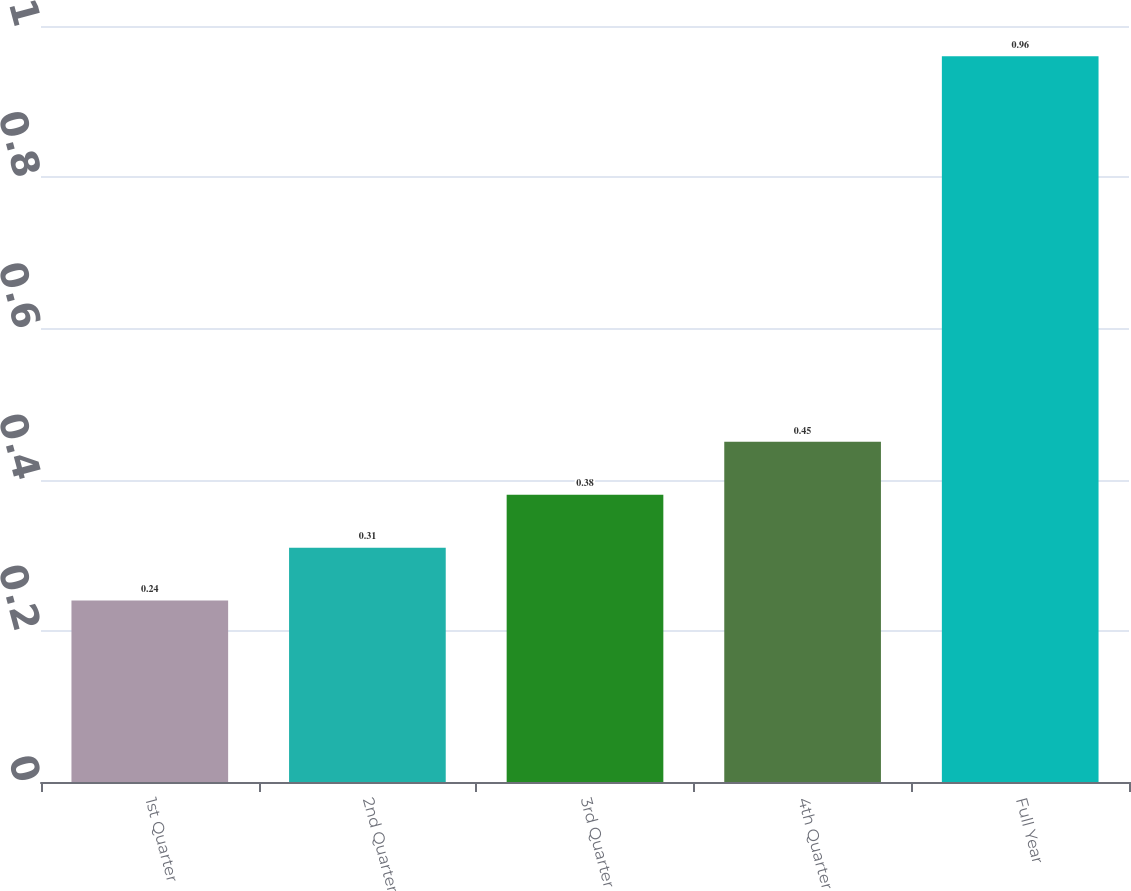<chart> <loc_0><loc_0><loc_500><loc_500><bar_chart><fcel>1st Quarter<fcel>2nd Quarter<fcel>3rd Quarter<fcel>4th Quarter<fcel>Full Year<nl><fcel>0.24<fcel>0.31<fcel>0.38<fcel>0.45<fcel>0.96<nl></chart> 